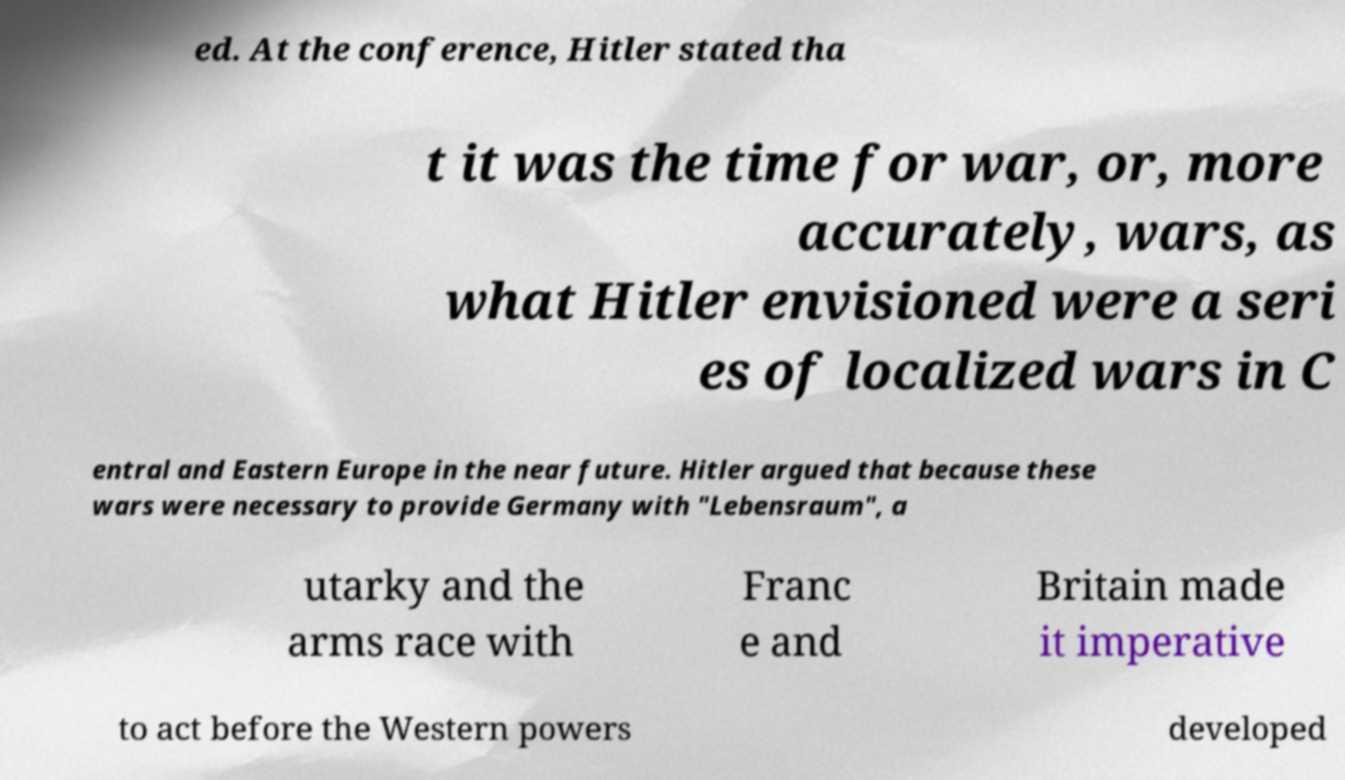Could you assist in decoding the text presented in this image and type it out clearly? ed. At the conference, Hitler stated tha t it was the time for war, or, more accurately, wars, as what Hitler envisioned were a seri es of localized wars in C entral and Eastern Europe in the near future. Hitler argued that because these wars were necessary to provide Germany with "Lebensraum", a utarky and the arms race with Franc e and Britain made it imperative to act before the Western powers developed 